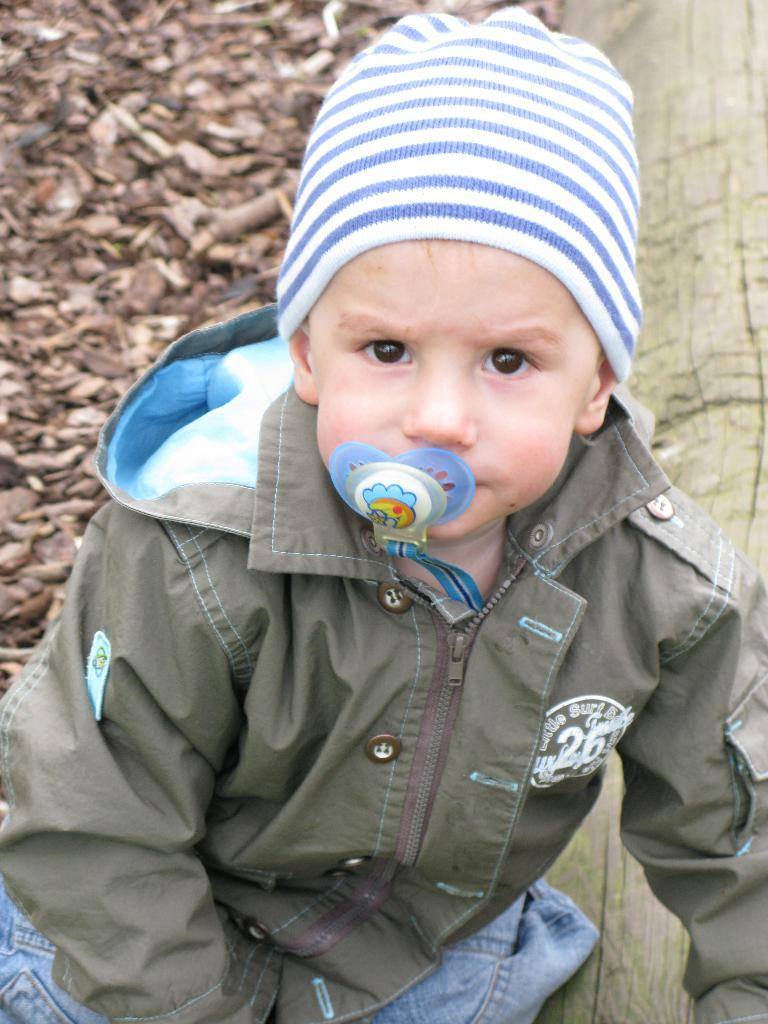What is the main subject of the image? The main subject of the image is a child. What is the child wearing on their head? The child is wearing a cap. What type of object can be seen in the image besides the child? There is a wooden log in the image. What can be seen in the background of the image? There are sticks visible in the background of the image. What type of pleasure can be seen being derived from the oven in the image? There is no oven present in the image, so it is not possible to determine any pleasure derived from it. 